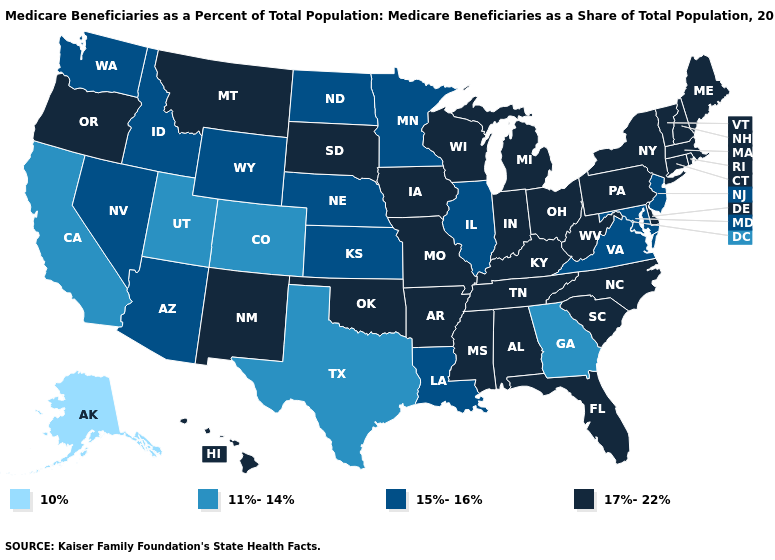What is the highest value in the USA?
Write a very short answer. 17%-22%. Name the states that have a value in the range 10%?
Answer briefly. Alaska. Among the states that border California , does Arizona have the highest value?
Answer briefly. No. Which states have the lowest value in the USA?
Keep it brief. Alaska. What is the value of North Dakota?
Keep it brief. 15%-16%. Name the states that have a value in the range 11%-14%?
Write a very short answer. California, Colorado, Georgia, Texas, Utah. Which states have the lowest value in the USA?
Give a very brief answer. Alaska. What is the lowest value in the South?
Keep it brief. 11%-14%. What is the value of Florida?
Short answer required. 17%-22%. What is the value of Oregon?
Concise answer only. 17%-22%. Which states have the highest value in the USA?
Write a very short answer. Alabama, Arkansas, Connecticut, Delaware, Florida, Hawaii, Indiana, Iowa, Kentucky, Maine, Massachusetts, Michigan, Mississippi, Missouri, Montana, New Hampshire, New Mexico, New York, North Carolina, Ohio, Oklahoma, Oregon, Pennsylvania, Rhode Island, South Carolina, South Dakota, Tennessee, Vermont, West Virginia, Wisconsin. What is the value of Mississippi?
Keep it brief. 17%-22%. Among the states that border Alabama , which have the highest value?
Short answer required. Florida, Mississippi, Tennessee. Which states have the highest value in the USA?
Quick response, please. Alabama, Arkansas, Connecticut, Delaware, Florida, Hawaii, Indiana, Iowa, Kentucky, Maine, Massachusetts, Michigan, Mississippi, Missouri, Montana, New Hampshire, New Mexico, New York, North Carolina, Ohio, Oklahoma, Oregon, Pennsylvania, Rhode Island, South Carolina, South Dakota, Tennessee, Vermont, West Virginia, Wisconsin. 